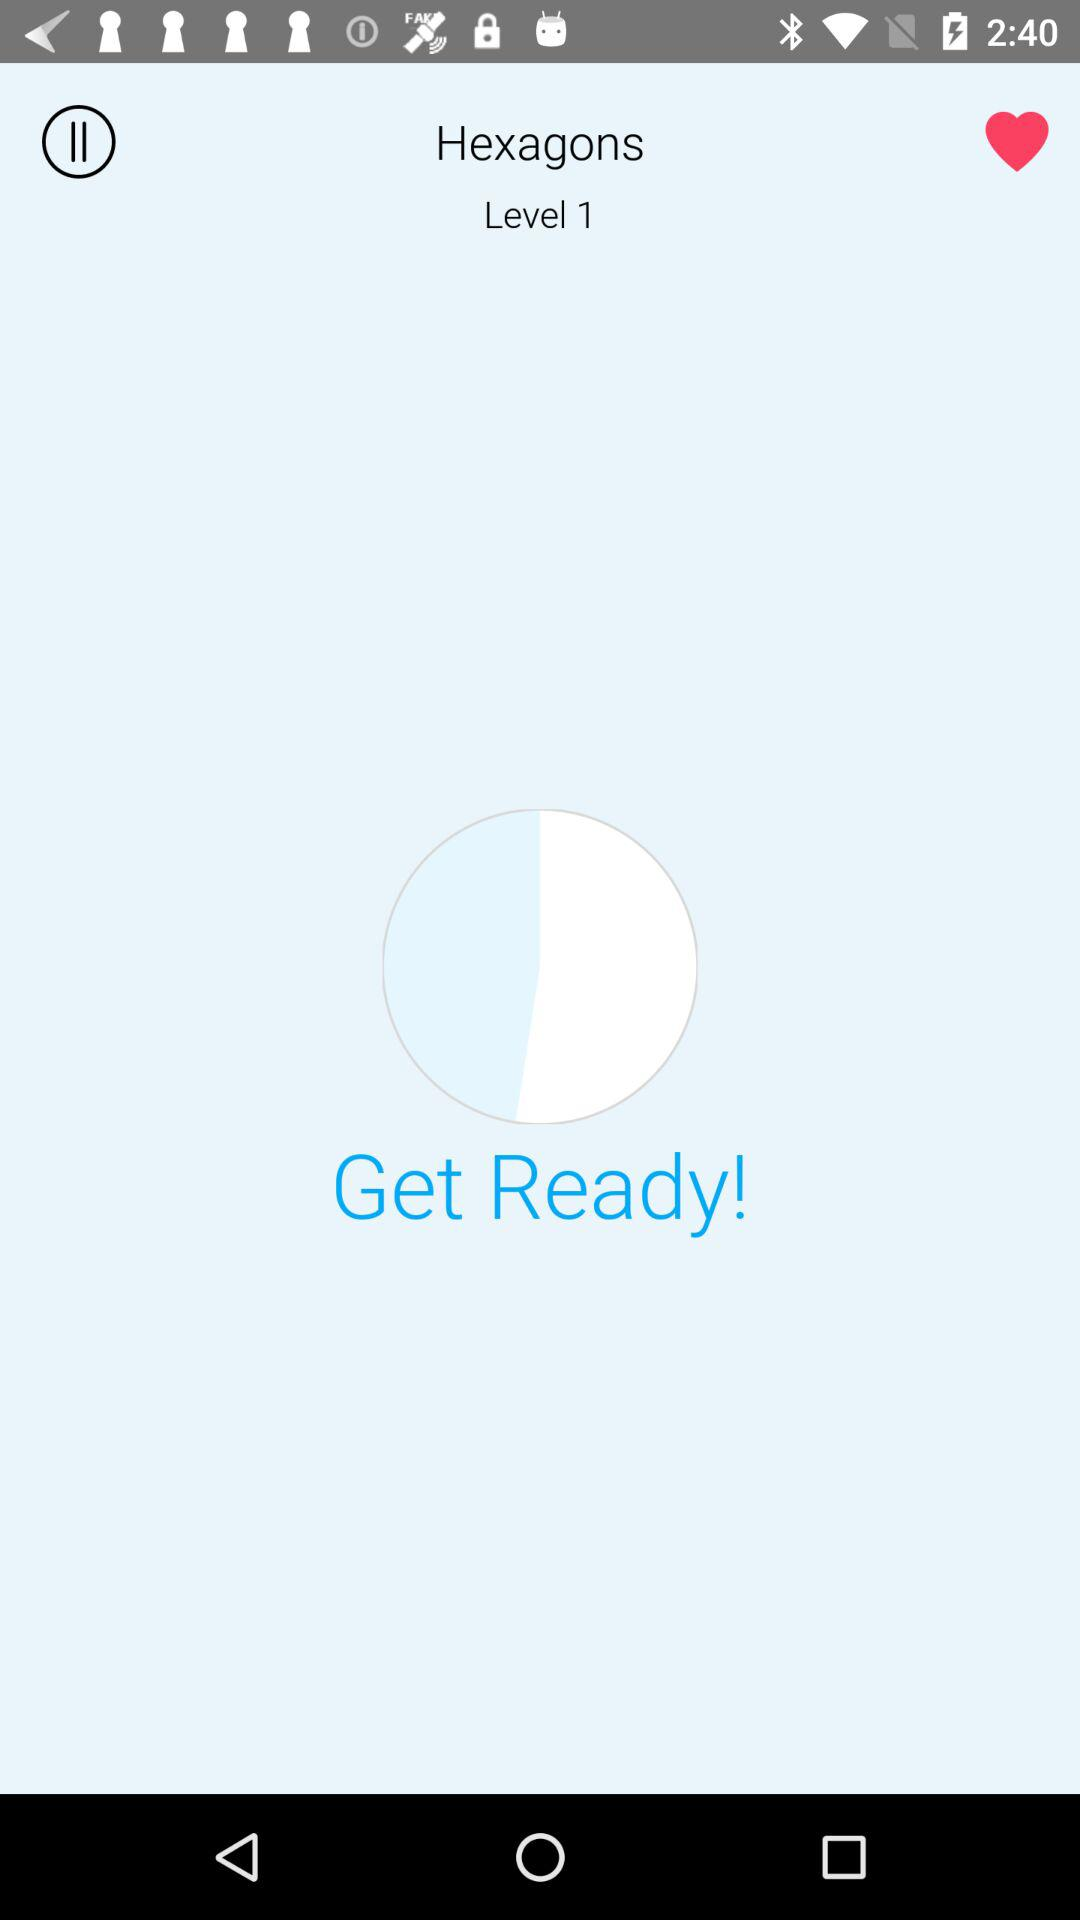Which level is it? The level is 1. 